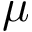Convert formula to latex. <formula><loc_0><loc_0><loc_500><loc_500>\mu</formula> 